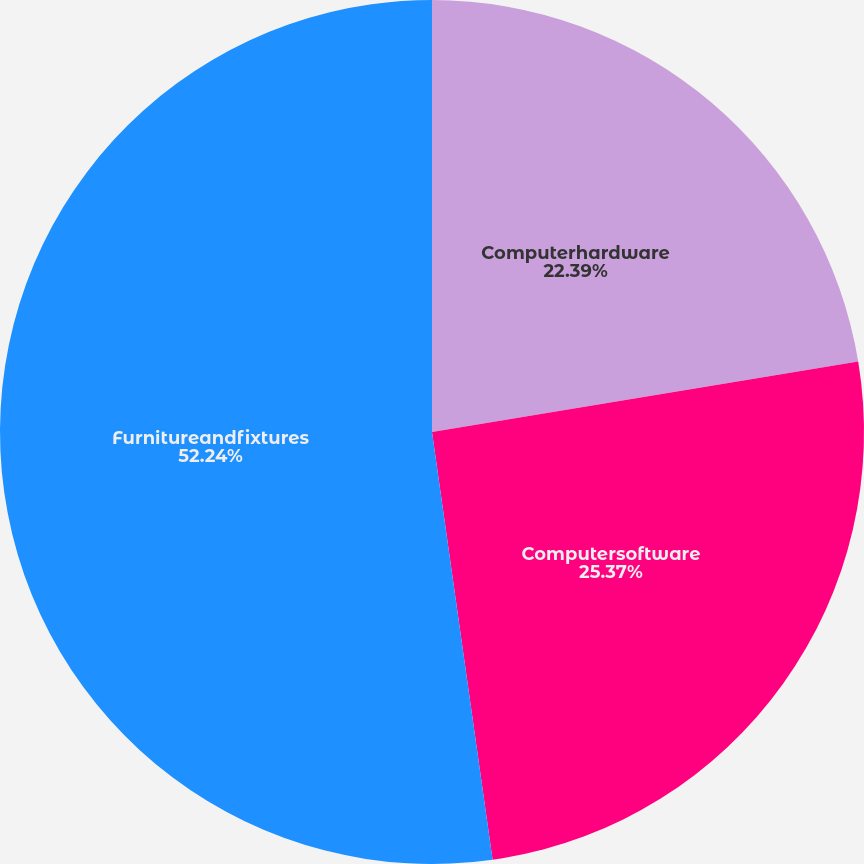Convert chart. <chart><loc_0><loc_0><loc_500><loc_500><pie_chart><fcel>Computerhardware<fcel>Computersoftware<fcel>Furnitureandfixtures<nl><fcel>22.39%<fcel>25.37%<fcel>52.24%<nl></chart> 